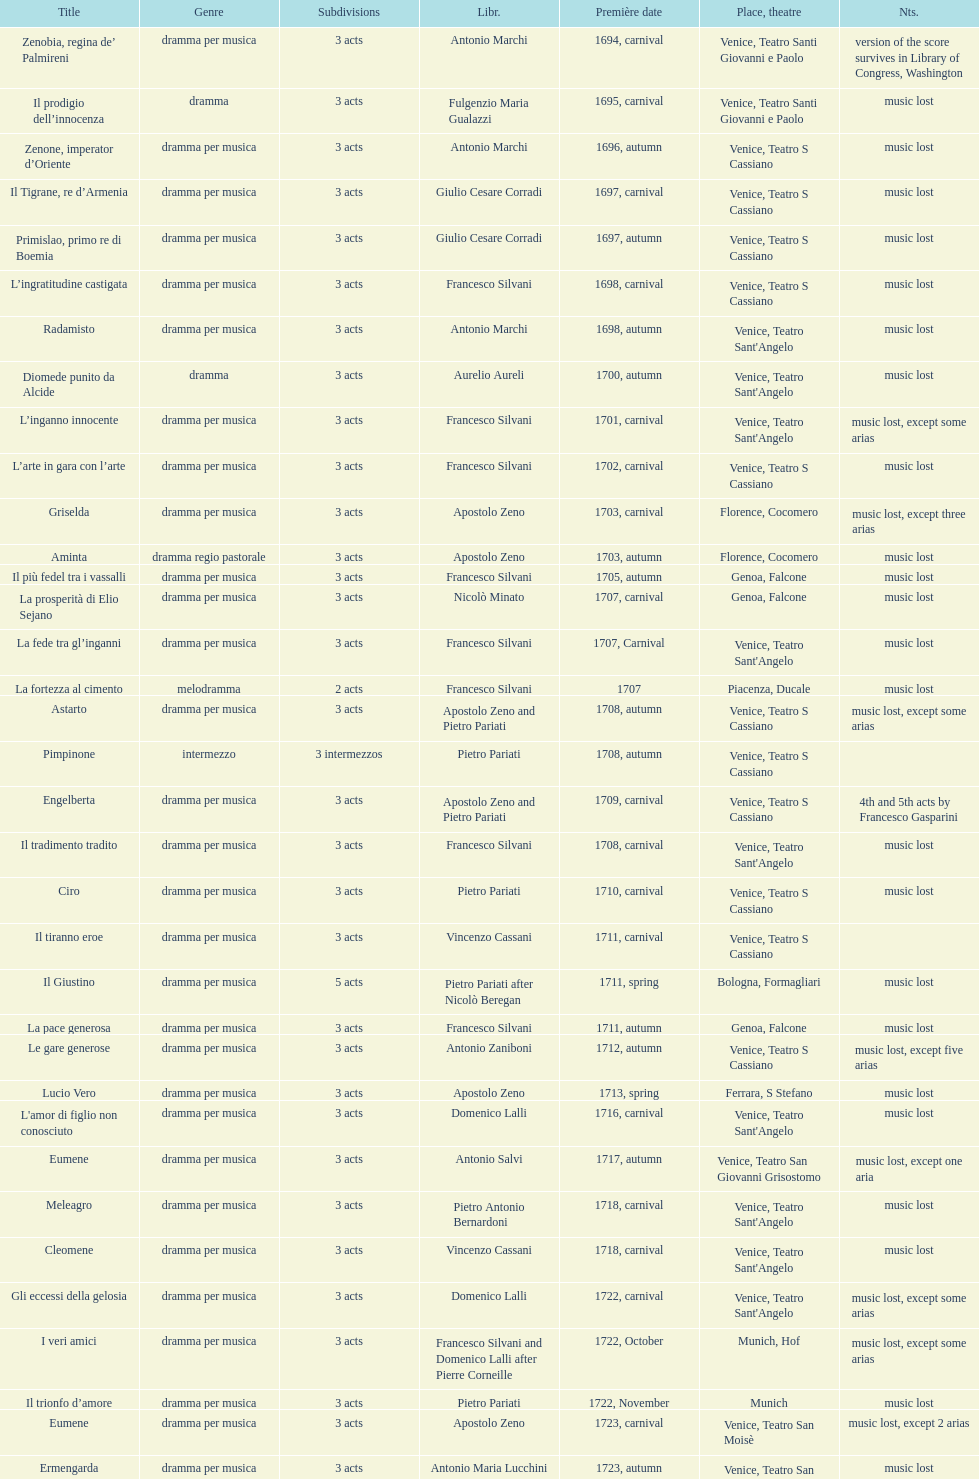What is next after ardelinda? Candalide. 